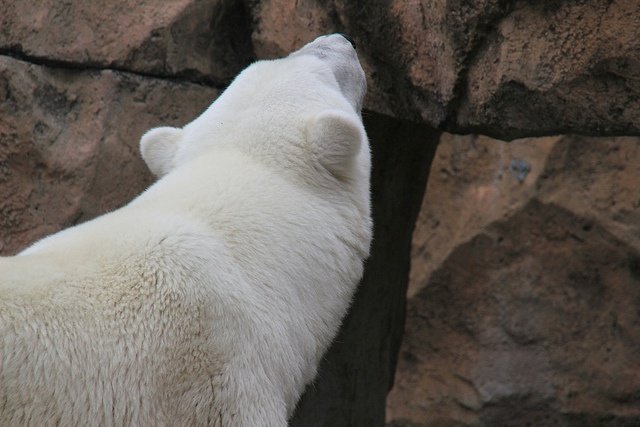Describe the objects in this image and their specific colors. I can see a bear in gray, darkgray, and lightgray tones in this image. 